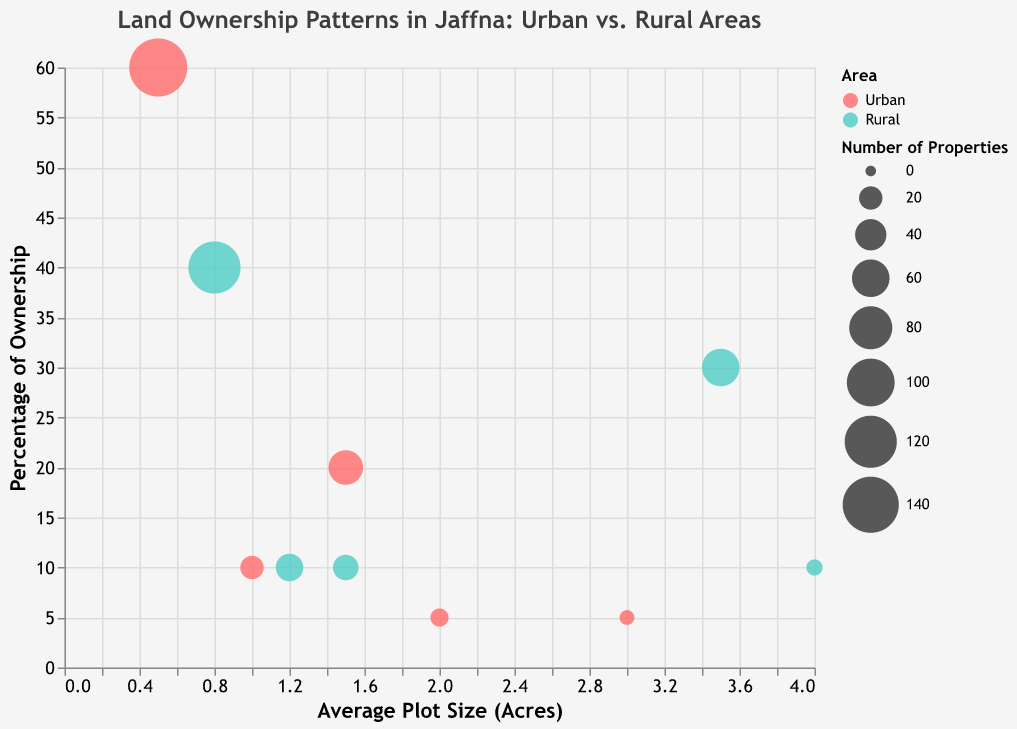What's the title of the figure? The title of the figure is displayed at the top and reads "Land Ownership Patterns in Jaffna: Urban vs. Rural Areas".
Answer: Land Ownership Patterns in Jaffna: Urban vs. Rural Areas Which area has a higher percentage of residential land ownership? By looking at the Percentage of Ownership axis, we see the Residential land type in Urban areas has a higher percentage (60%) compared to Rural areas which have 40%.
Answer: Urban What is the average plot size of agricultural land in rural areas? The tooltip shows that the average plot size for Agricultural land in Rural areas is 3.5 acres.
Answer: 3.5 acres How many types of land ownership are represented in the Urban area? The Urban area includes Residential, Commercial, Agricultural, Government, and Vacant types, indicated by the color-coded bubbles. This totals to 5 types.
Answer: 5 Which land type in the Urban area has the smallest average plot size? By referring to the Average Plot Size axis and the tooltips, the Residential land type in Urban areas has the smallest average plot size of 0.5 acres.
Answer: Residential Which area has more properties of agricultural land, and how many are there? The Urban area has 10 Agricultural properties and the Rural area has 60, so the Rural area has more Agricultural properties.
Answer: Rural, 60 Compare the percentage of commercial land ownership in Urban and Rural areas. Which one is higher? The tooltip reveals that the percentage of Commercial land ownership is higher in Urban areas (20%) compared to Rural areas (10%).
Answer: Urban What is the difference in the average plot size between the largest Government-owned land in Rural and Urban areas? The average plot size for Government land in Rural areas is 4.0 acres, and in Urban areas, it is 3.0 acres. The difference is 4.0 - 3.0 = 1.0 acre.
Answer: 1.0 acre What is the total number of properties in both Urban and Rural areas for vacant lands? Vacant land in Urban areas has 20 properties, whereas in Rural areas, it has 25 properties. The total is 20 + 25 = 45 properties.
Answer: 45 Which land type has the largest bubble in the Urban area, and what does it represent? The Residential land type in Urban areas has the largest bubble, representing 150 properties.
Answer: Residential, 150 properties 